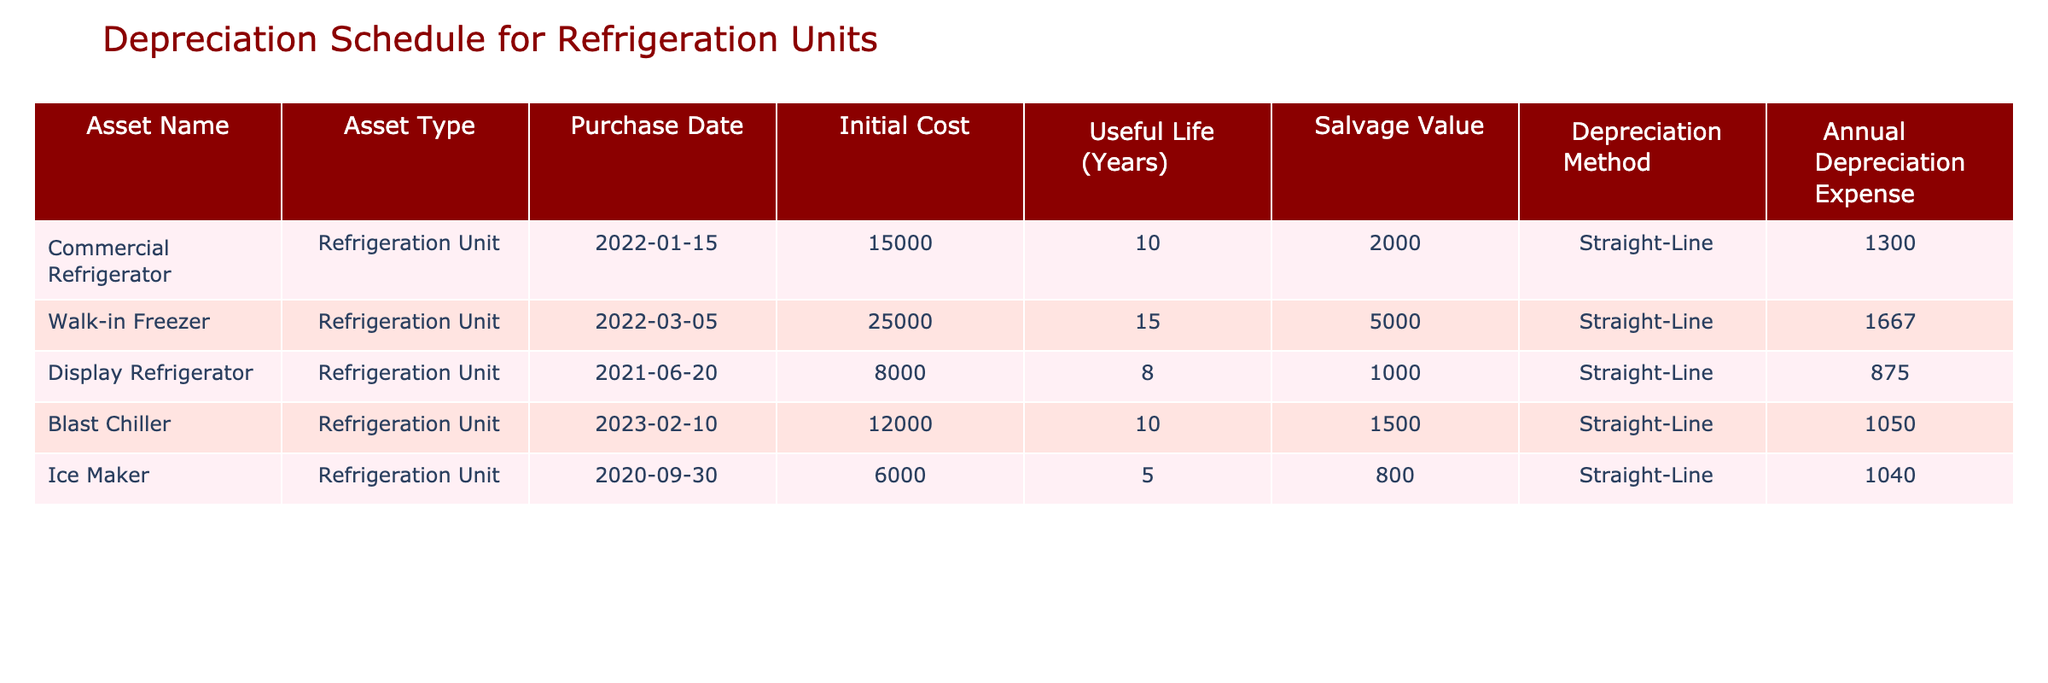What is the initial cost of the Display Refrigerator? The initial cost is listed in the table under the 'Initial Cost' column for the Display Refrigerator row, which shows a value of 8000.
Answer: 8000 What is the annual depreciation expense for the Walk-in Freezer? The annual depreciation expense for the Walk-in Freezer can be found in the corresponding row in the 'Annual Depreciation Expense' column, which is 1667.
Answer: 1667 Which refrigeration unit has the longest useful life? To find the refrigeration unit with the longest useful life, we look at the 'Useful Life (Years)' column and see that the Walk-in Freezer has a useful life of 15 years, which is the highest among the listed units.
Answer: Walk-in Freezer Is the annual depreciation expense for the Ice Maker greater than 1000? Checking the 'Annual Depreciation Expense' value for the Ice Maker, it is listed as 1040, which is greater than 1000.
Answer: Yes What is the total initial cost of all refrigeration units combined? To find the total initial cost, we add the initial costs of all refrigeration units: 15000 + 25000 + 8000 + 12000 + 6000 = 56000. Therefore, the total initial cost is 56000.
Answer: 56000 What is the average annual depreciation expense for all refrigeration units? To calculate the average, first sum the annual depreciation expenses: 1300 + 1667 + 875 + 1050 + 1040 = 4932. Then divide by the number of units (5): 4932 / 5 = 986.4, rounded gives 986.
Answer: 986 Which refrigeration unit has the highest salvage value? In the table, the highest salvage value is found in the Walk-in Freezer row, where it is noted as 5000, which is the largest amount listed.
Answer: Walk-in Freezer If you were to write off the commercial refrigerator, how much of its initial value would remain after the first year of depreciation? The initial cost of the Commercial Refrigerator is 15000, and the annual depreciation expense is 1300. After one year, the remaining value is calculated as 15000 - 1300 = 13700.
Answer: 13700 Are there any refrigeration units with a salvage value of less than 1000? Looking at the 'Salvage Value' column, both the Display Refrigerator (1000) and Ice Maker (800) have values below 1000. Therefore, there are units with a salvage value of less than 1000.
Answer: Yes 